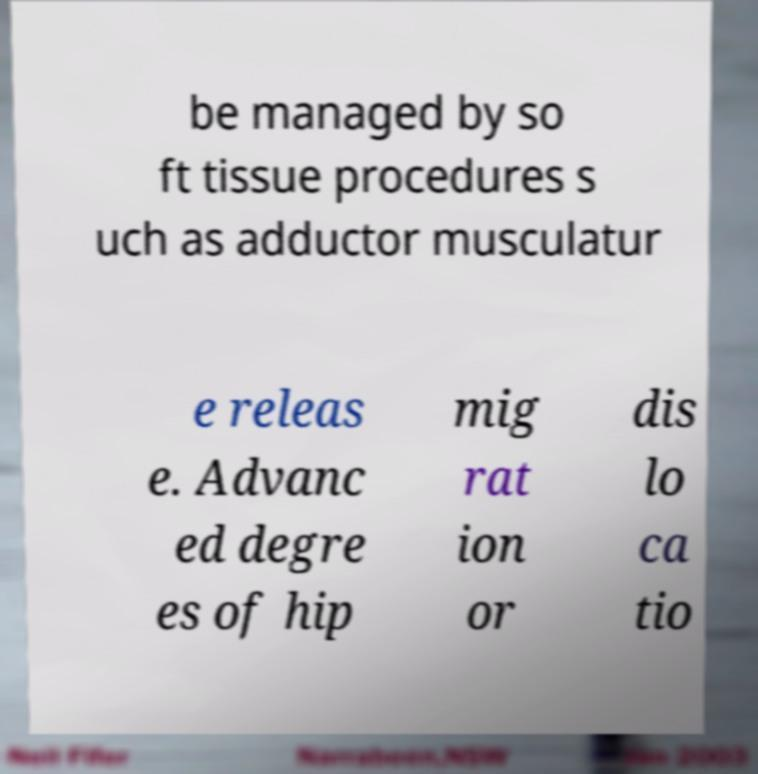There's text embedded in this image that I need extracted. Can you transcribe it verbatim? be managed by so ft tissue procedures s uch as adductor musculatur e releas e. Advanc ed degre es of hip mig rat ion or dis lo ca tio 